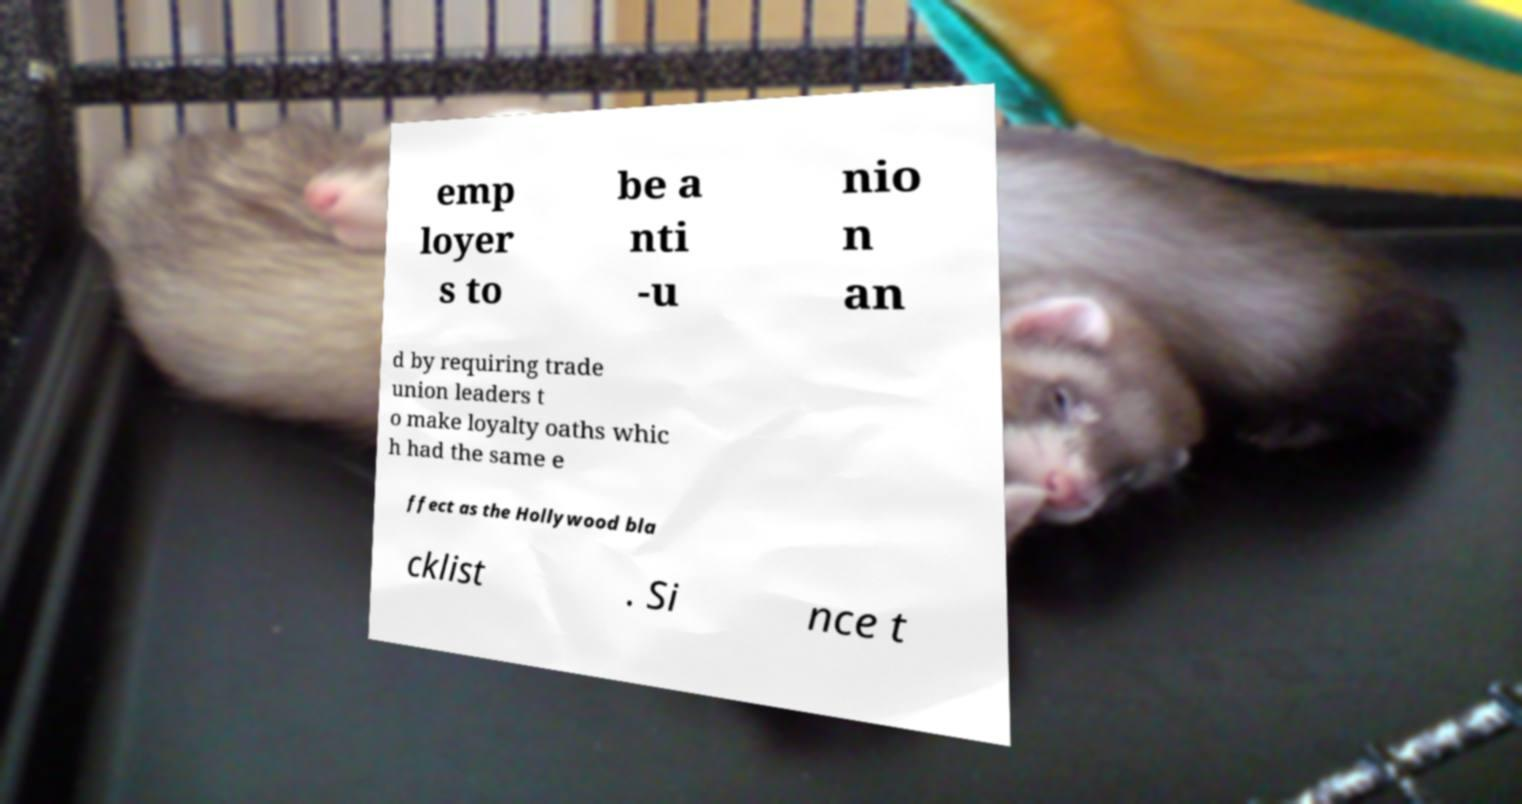What messages or text are displayed in this image? I need them in a readable, typed format. emp loyer s to be a nti -u nio n an d by requiring trade union leaders t o make loyalty oaths whic h had the same e ffect as the Hollywood bla cklist . Si nce t 